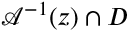Convert formula to latex. <formula><loc_0><loc_0><loc_500><loc_500>\mathcal { A } ^ { - 1 } ( z ) \cap D</formula> 